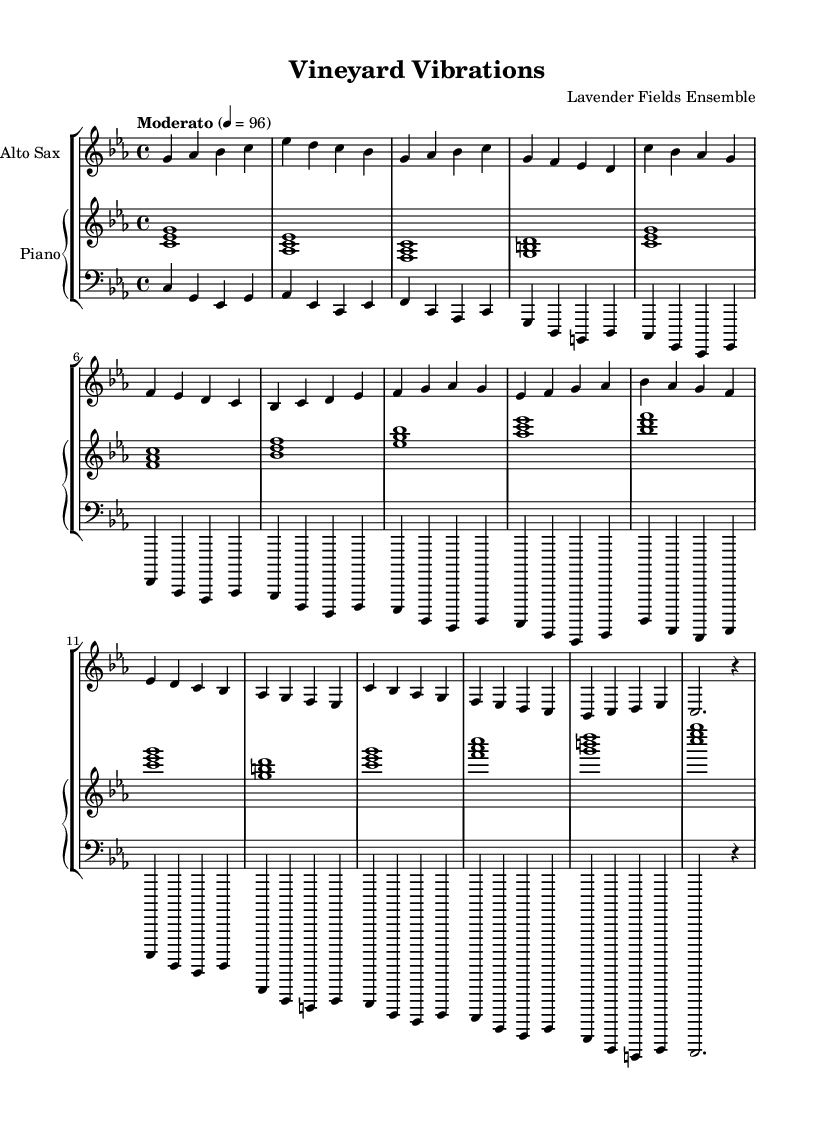What is the key signature of this music? The key signature is found at the beginning of the staff, which shows B flat and E flat. This indicates that the piece is in C minor, as it has three flats.
Answer: C minor What is the time signature? The time signature is located near the beginning of the music, indicated as 4/4, which means four beats per measure.
Answer: 4/4 What is the tempo marking given in the score? The tempo marking at the beginning indicates a moderate pace, with the term "Moderato" and a metronome marking of 96 beats per minute, suggesting a moderate speed.
Answer: Moderato, 96 How many sections are present in this composition? The structure can be observed by looking for distinct patterns or repeats; there are three main sections labeled as the Intro, A Section, B Section, and an Outro. Therefore, counting these gives a total of four distinct sections.
Answer: Four What instruments are used in this piece? The instruments are indicated at the start of each staff. There is an alto saxophone, a piano, and a bass, making the ensemble constitute three main parts: saxophone, piano, and bass.
Answer: Alto Sax, Piano, Bass What type of jazz does this piece represent? This composition incorporates environmental sounds and elements inspired by a vineyard ambiance, providing a unique experimental jazz characteristic that blends nature with musical creativity.
Answer: Experimental jazz 